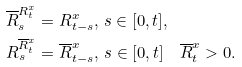Convert formula to latex. <formula><loc_0><loc_0><loc_500><loc_500>& \overline { R } ^ { R ^ { x } _ { t } } _ { s } = R ^ { x } _ { t - s } , \, s \in [ 0 , t ] , \\ & R ^ { \overline { R } ^ { x } _ { t } } _ { s } = \overline { R } ^ { x } _ { t - s } , \, s \in [ 0 , t ] \quad \overline { R } ^ { x } _ { t } > 0 .</formula> 